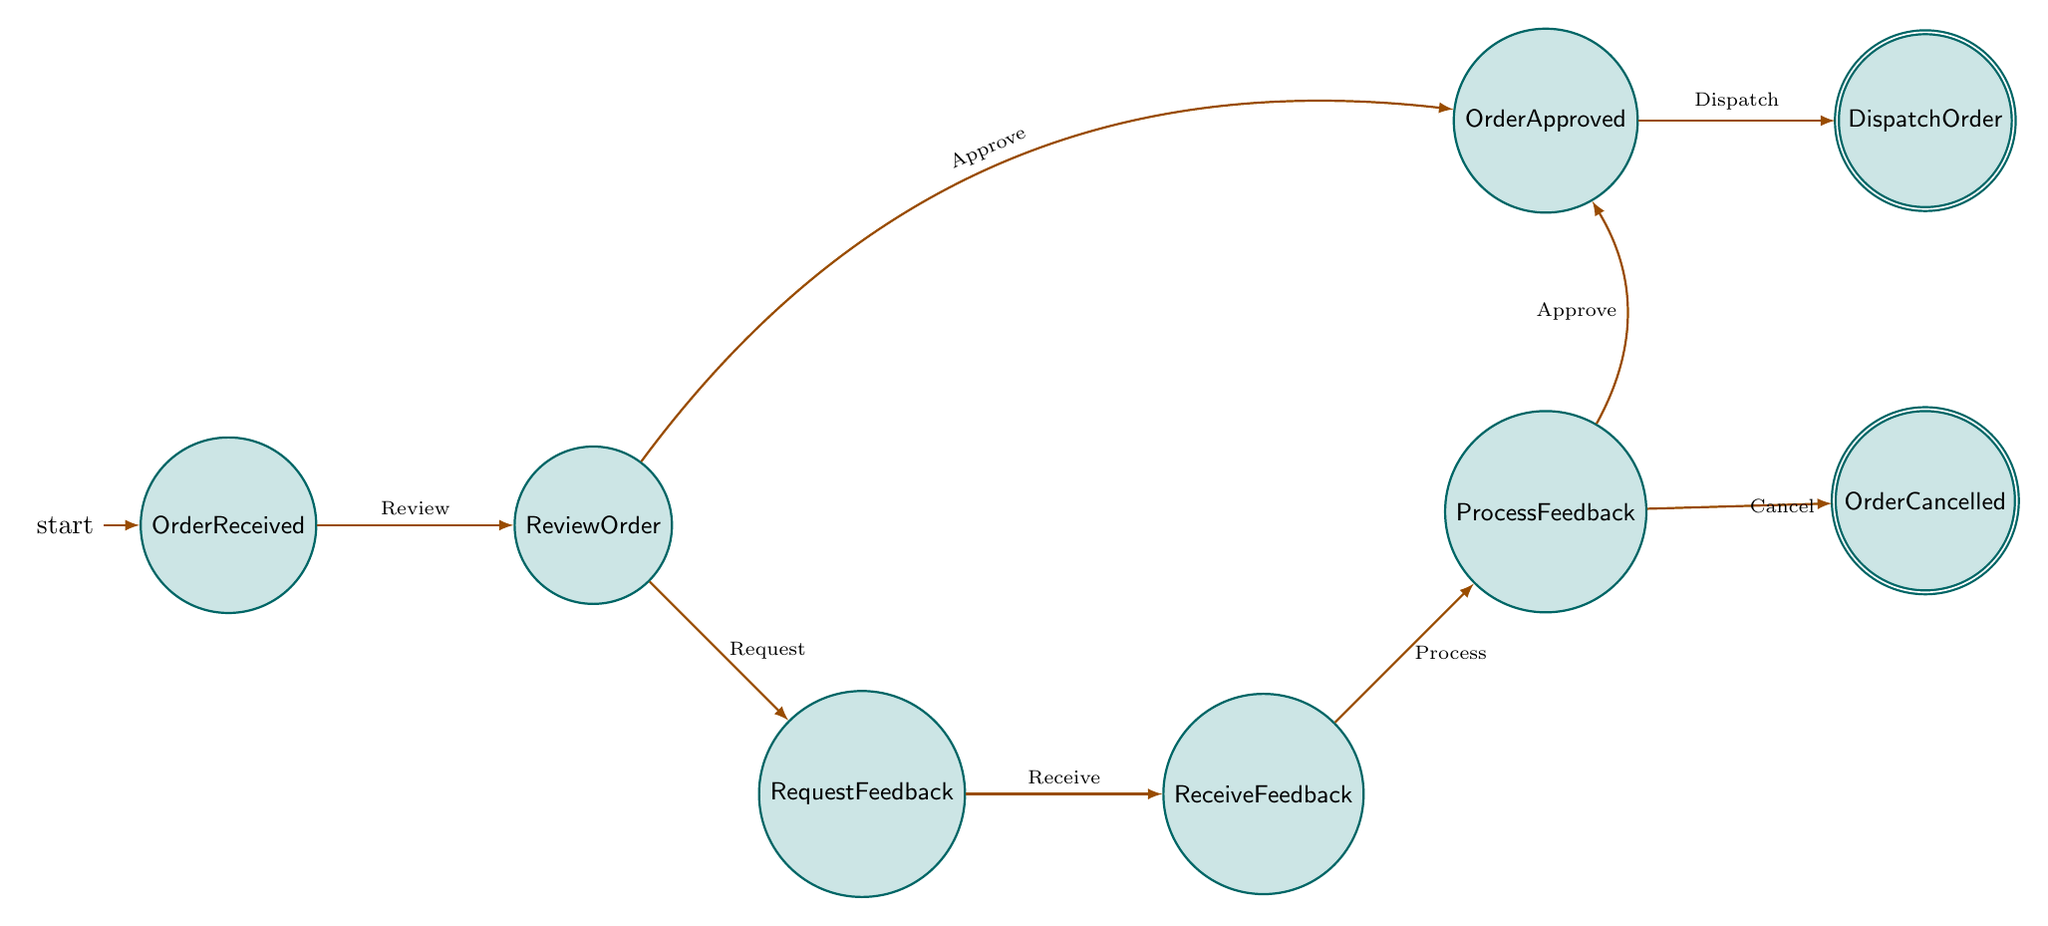What is the initial state of the process? The initial state is defined clearly in the diagram as "OrderReceived." This is the state where the order from the art studio is first received.
Answer: OrderReceived How many states are there in total? By counting the unique states presented in the diagram, there are a total of seven distinct states: OrderReceived, ReviewOrder, RequestFeedback, ReceiveFeedback, ProcessFeedback, OrderApproved, and two final states (DispatchOrder and OrderCancelled).
Answer: Seven Which state comes after "ReviewOrder" when the order is approved? The state that follows "ReviewOrder" upon approval is "OrderApproved." The transition from ReviewOrder to OrderApproved indicates that the order is approved and can proceed.
Answer: OrderApproved What are the two final states in this process? The two final states are "DispatchOrder" and "OrderCancelled." These indicate the completion of the process either by dispatching the order or cancelling it based on feedback or issues.
Answer: DispatchOrder and OrderCancelled What transition occurs from "RequestFeedback"? The transition from "RequestFeedback" leads to "ReceiveFeedback." This indicates that after requesting feedback, the next action is to receive it.
Answer: ReceiveFeedback In which state can the order be cancelled? The order can be cancelled in the "ProcessFeedback" state. If the feedback indicates issues, the order can transition to "OrderCancelled."
Answer: ProcessFeedback If an order is approved, what is the next immediate action? If the order is approved, the next immediate action is "DispatchOrder." This follows logically from the "OrderApproved" state, where the order is then dispatched.
Answer: DispatchOrder What is the purpose of the "ReceiveFeedback" state? The purpose of the "ReceiveFeedback" state is to collect and review the feedback received from the art studio about any issues or special requests related to the order.
Answer: ReceiveFeedback What action leads to the "OrderApproved" state from "ProcessFeedback"? The action that leads to the "OrderApproved" state from "ProcessFeedback" is the approval of the feedback processed. This indicates that the feedback was satisfactory for proceeding with the order.
Answer: Approve 